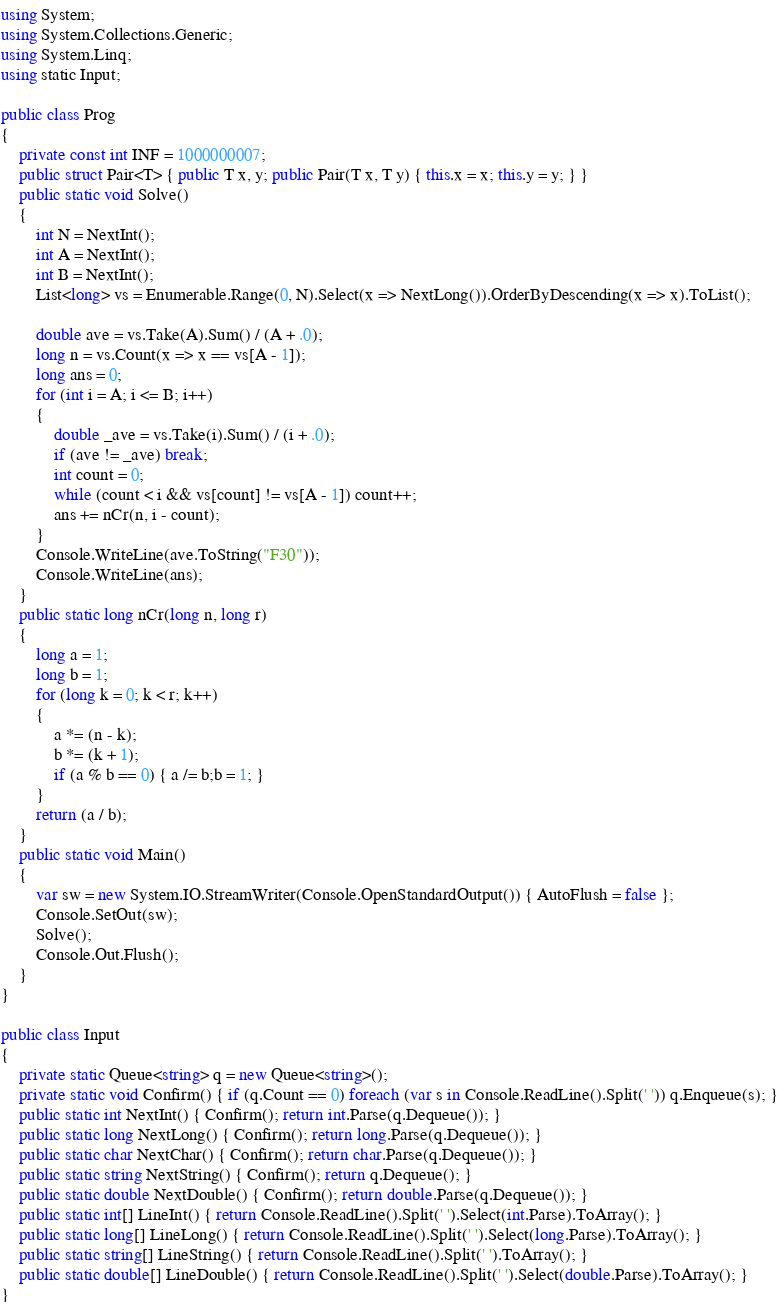Convert code to text. <code><loc_0><loc_0><loc_500><loc_500><_C#_>using System;
using System.Collections.Generic;
using System.Linq;
using static Input;

public class Prog
{
    private const int INF = 1000000007;
    public struct Pair<T> { public T x, y; public Pair(T x, T y) { this.x = x; this.y = y; } }
    public static void Solve()
    {
        int N = NextInt();
        int A = NextInt();
        int B = NextInt();
        List<long> vs = Enumerable.Range(0, N).Select(x => NextLong()).OrderByDescending(x => x).ToList();

        double ave = vs.Take(A).Sum() / (A + .0);
        long n = vs.Count(x => x == vs[A - 1]);
        long ans = 0;
        for (int i = A; i <= B; i++)
        {
            double _ave = vs.Take(i).Sum() / (i + .0);
            if (ave != _ave) break;
            int count = 0;
            while (count < i && vs[count] != vs[A - 1]) count++;
            ans += nCr(n, i - count);
        }
        Console.WriteLine(ave.ToString("F30"));
        Console.WriteLine(ans);
    }
    public static long nCr(long n, long r)
    {
        long a = 1;
        long b = 1;
        for (long k = 0; k < r; k++)
        {
            a *= (n - k);
            b *= (k + 1);
            if (a % b == 0) { a /= b;b = 1; }
        }
        return (a / b);
    }
    public static void Main()
    {
        var sw = new System.IO.StreamWriter(Console.OpenStandardOutput()) { AutoFlush = false };
        Console.SetOut(sw);
        Solve();
        Console.Out.Flush();
    }
}

public class Input
{
    private static Queue<string> q = new Queue<string>();
    private static void Confirm() { if (q.Count == 0) foreach (var s in Console.ReadLine().Split(' ')) q.Enqueue(s); }
    public static int NextInt() { Confirm(); return int.Parse(q.Dequeue()); }
    public static long NextLong() { Confirm(); return long.Parse(q.Dequeue()); }
    public static char NextChar() { Confirm(); return char.Parse(q.Dequeue()); }
    public static string NextString() { Confirm(); return q.Dequeue(); }
    public static double NextDouble() { Confirm(); return double.Parse(q.Dequeue()); }
    public static int[] LineInt() { return Console.ReadLine().Split(' ').Select(int.Parse).ToArray(); }
    public static long[] LineLong() { return Console.ReadLine().Split(' ').Select(long.Parse).ToArray(); }
    public static string[] LineString() { return Console.ReadLine().Split(' ').ToArray(); }
    public static double[] LineDouble() { return Console.ReadLine().Split(' ').Select(double.Parse).ToArray(); }
}
</code> 